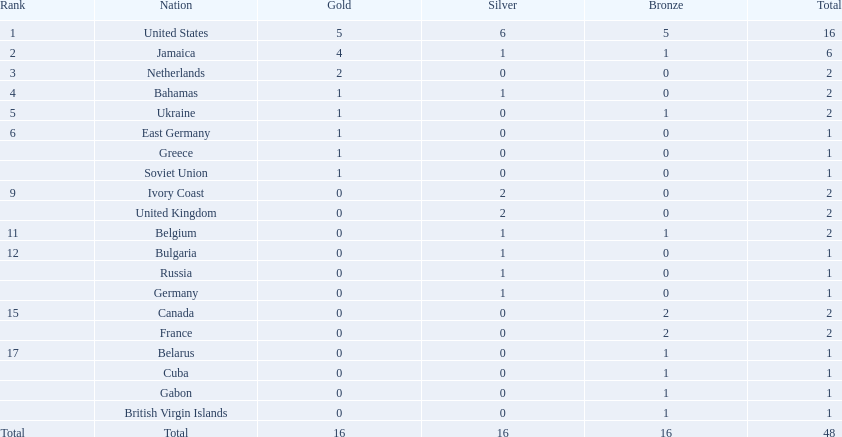Which states were involved? United States, Jamaica, Netherlands, Bahamas, Ukraine, East Germany, Greece, Soviet Union, Ivory Coast, United Kingdom, Belgium, Bulgaria, Russia, Germany, Canada, France, Belarus, Cuba, Gabon, British Virgin Islands. How many gold trophies were obtained by each? 5, 4, 2, 1, 1, 1, 1, 1, 0, 0, 0, 0, 0, 0, 0, 0, 0, 0, 0, 0. And which state garnered the most? United States. 